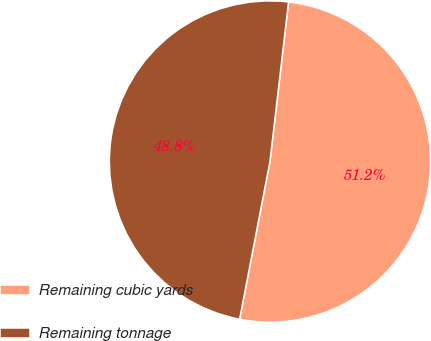Convert chart. <chart><loc_0><loc_0><loc_500><loc_500><pie_chart><fcel>Remaining cubic yards<fcel>Remaining tonnage<nl><fcel>51.18%<fcel>48.82%<nl></chart> 